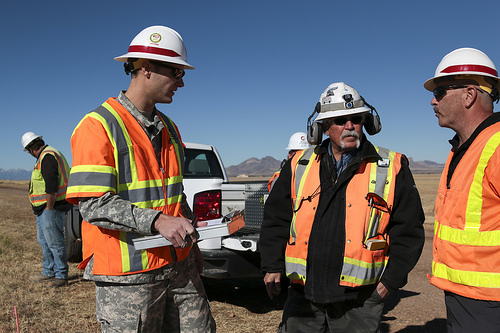<image>
Can you confirm if the truck is behind the clipboard? Yes. From this viewpoint, the truck is positioned behind the clipboard, with the clipboard partially or fully occluding the truck. 